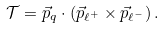Convert formula to latex. <formula><loc_0><loc_0><loc_500><loc_500>\mathcal { T } = \vec { p } _ { q } \cdot ( \vec { p } _ { \ell ^ { + } } \times \vec { p } _ { \ell ^ { - } } ) \, .</formula> 